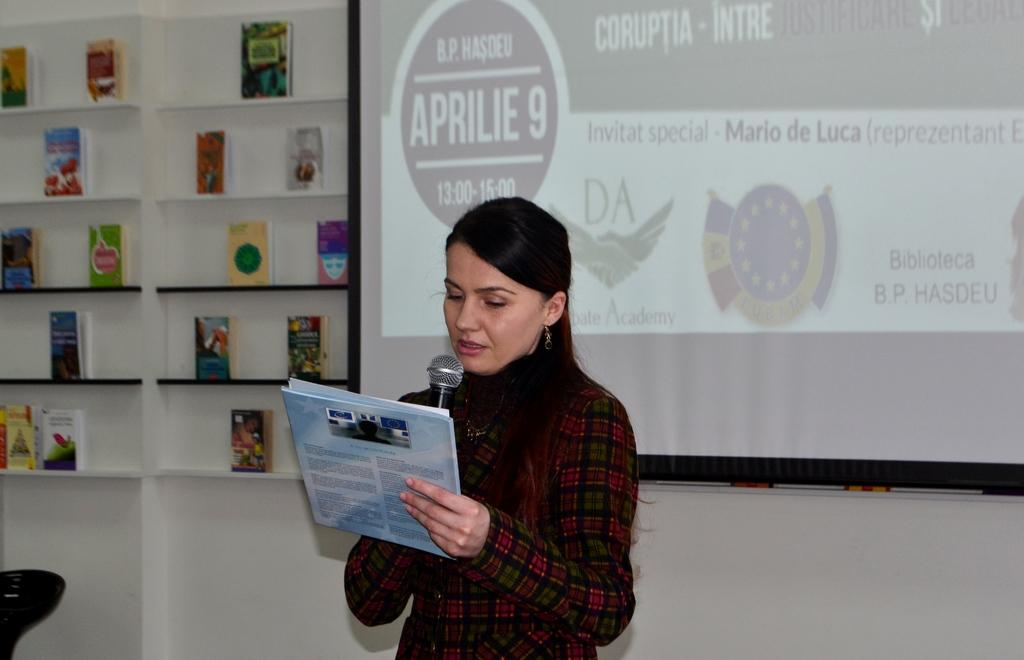Who is in the image? There is a person in the image. What is the person holding? The person is holding a microphone. What is the person doing with the microphone? The person is reading. What can be seen on the shelves in the image? There are books on the shelves. What is behind the person in the image? There is a screen behind the person. What is the color of the wall in the image? There is a white wall in the image. What type of meat is being prepared on the tramp in the image? There is no tramp or meat present in the image. How many lights are visible on the ceiling in the image? There is no mention of lights or a ceiling in the image. 